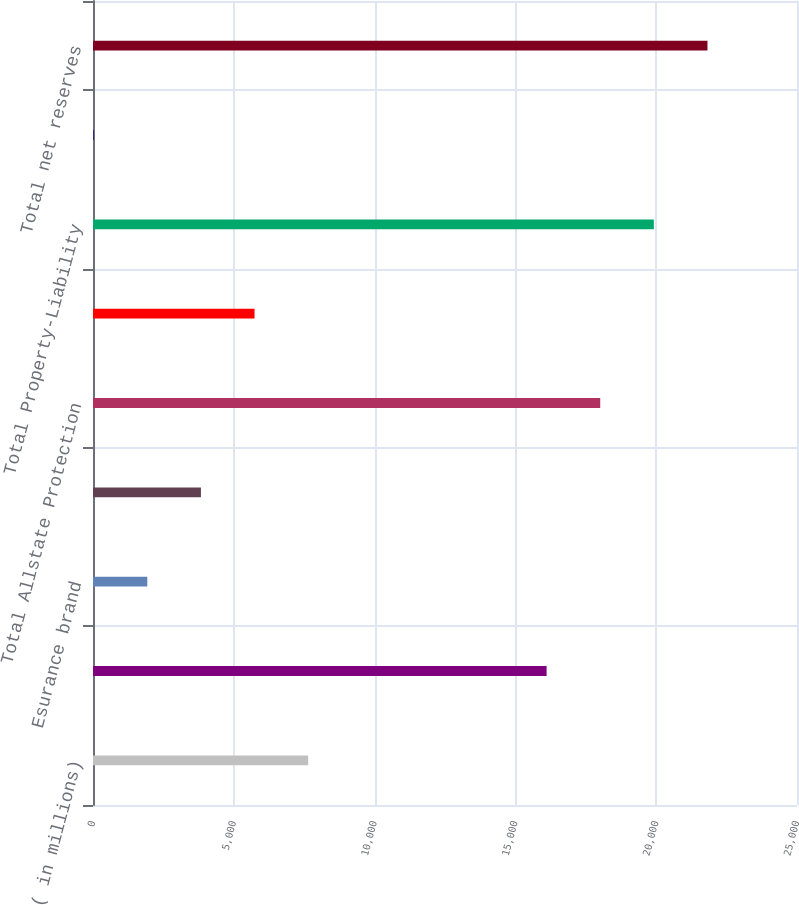Convert chart. <chart><loc_0><loc_0><loc_500><loc_500><bar_chart><fcel>( in millions)<fcel>Allstate brand<fcel>Esurance brand<fcel>Encompass brand<fcel>Total Allstate Protection<fcel>Discontinued Lines and<fcel>Total Property-Liability<fcel>Service Businesses<fcel>Total net reserves<nl><fcel>7640.8<fcel>16108<fcel>1928.2<fcel>3832.4<fcel>18012.2<fcel>5736.6<fcel>19916.4<fcel>24<fcel>21820.6<nl></chart> 